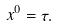Convert formula to latex. <formula><loc_0><loc_0><loc_500><loc_500>x ^ { 0 } = \tau .</formula> 